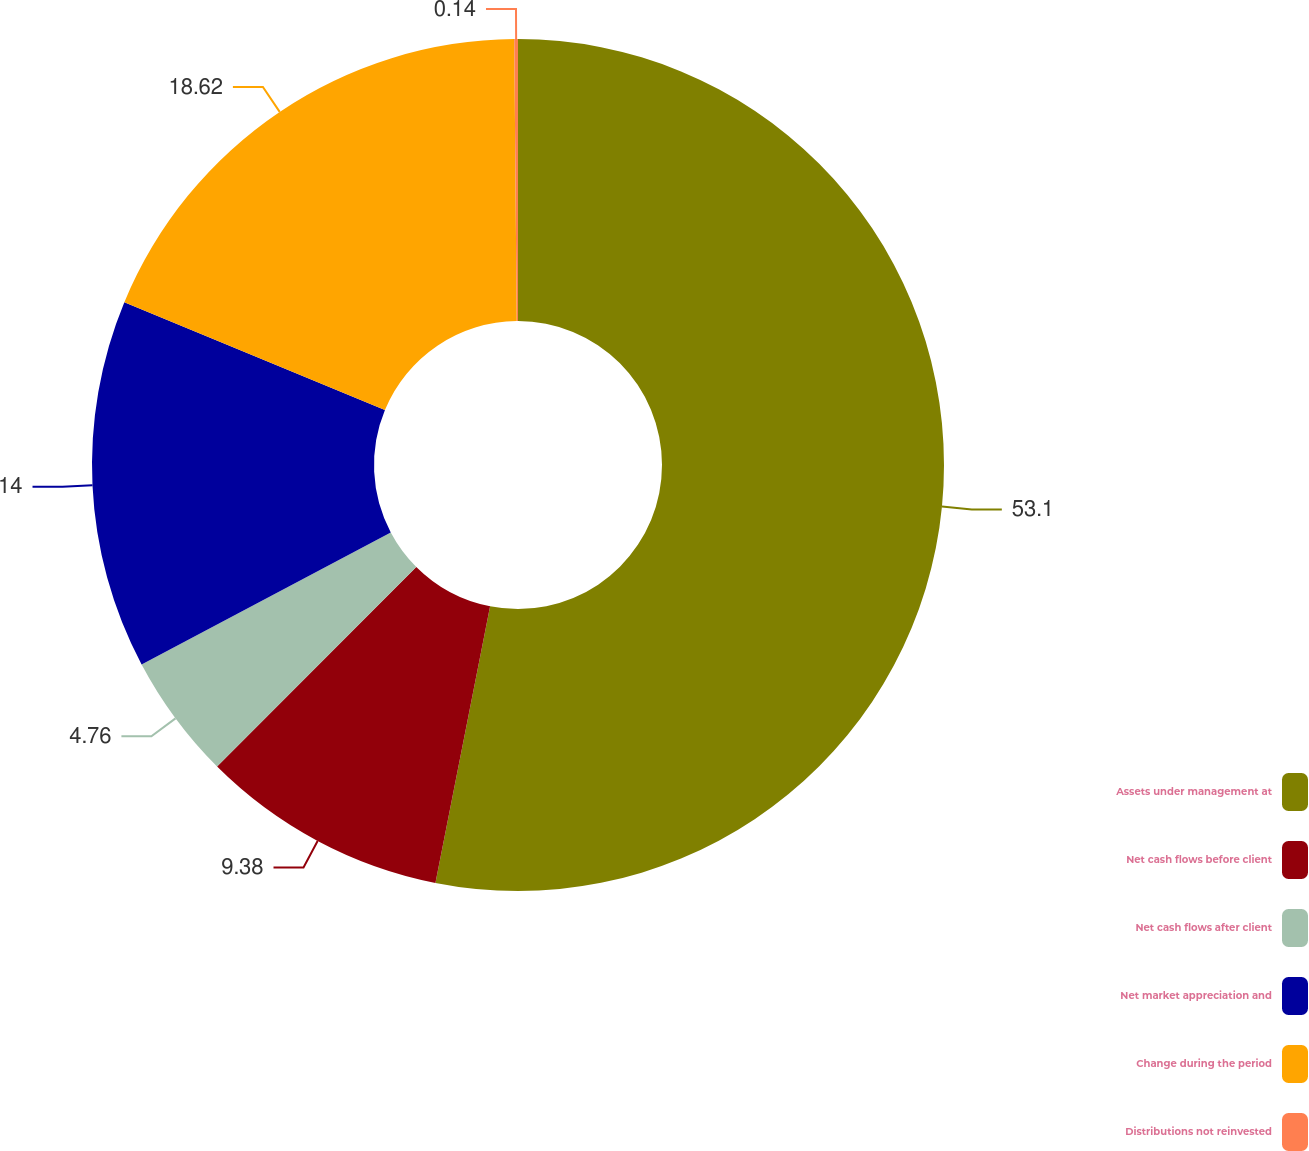Convert chart to OTSL. <chart><loc_0><loc_0><loc_500><loc_500><pie_chart><fcel>Assets under management at<fcel>Net cash flows before client<fcel>Net cash flows after client<fcel>Net market appreciation and<fcel>Change during the period<fcel>Distributions not reinvested<nl><fcel>53.11%<fcel>9.38%<fcel>4.76%<fcel>14.0%<fcel>18.62%<fcel>0.14%<nl></chart> 